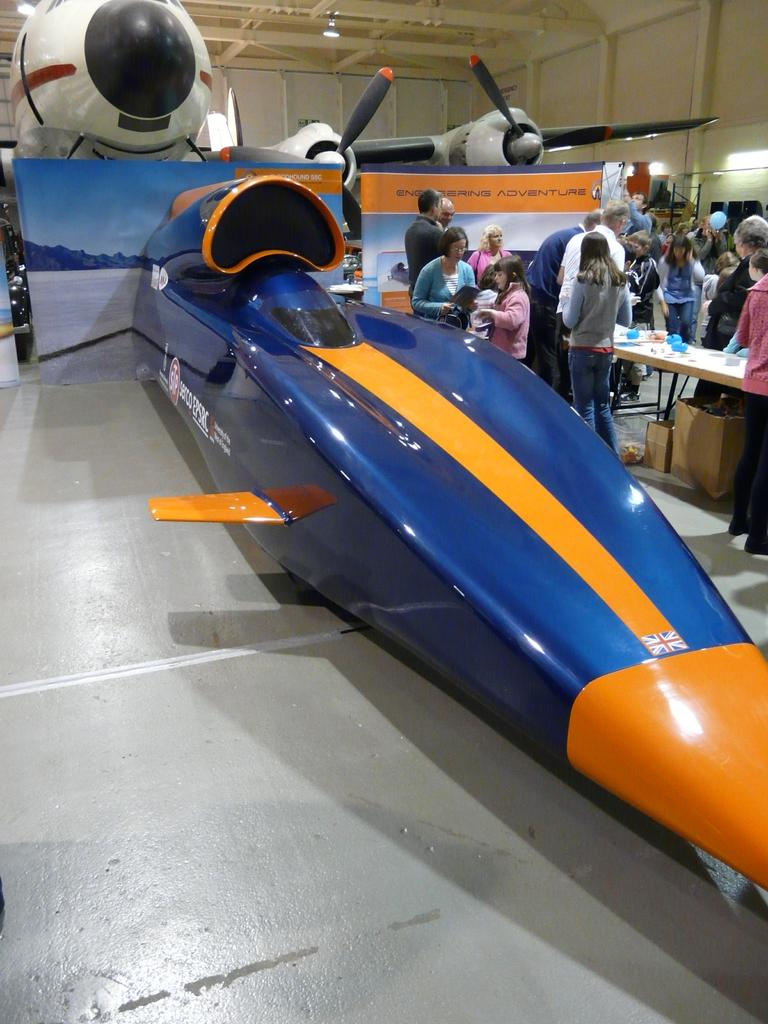What type of vehicle can be seen in the background of the image? There is an aircraft in the background of the image. What color is the airplane that is prominently displayed in the image? The airplane on the front side of the image is blue. Can you describe the people visible on the right side of the image? Unfortunately, the facts provided do not give any details about the people on the right side of the image. Where can the store selling scarves be found in the image? There is no store or scarves present in the image. Is the whip used by the people on the right side of the image? There are no people or whips mentioned in the provided facts, so we cannot determine if a whip is being used. 